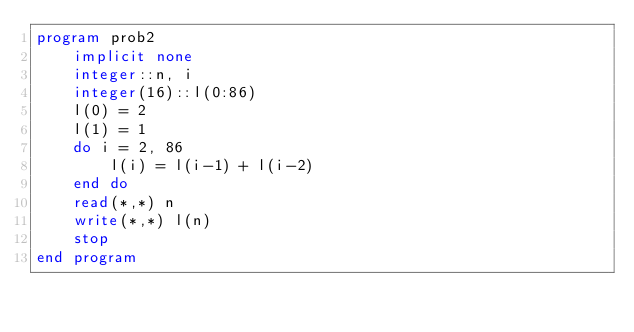<code> <loc_0><loc_0><loc_500><loc_500><_FORTRAN_>program prob2
    implicit none
    integer::n, i
    integer(16)::l(0:86)
    l(0) = 2
    l(1) = 1
    do i = 2, 86
        l(i) = l(i-1) + l(i-2)
    end do
    read(*,*) n
    write(*,*) l(n)
    stop
end program</code> 